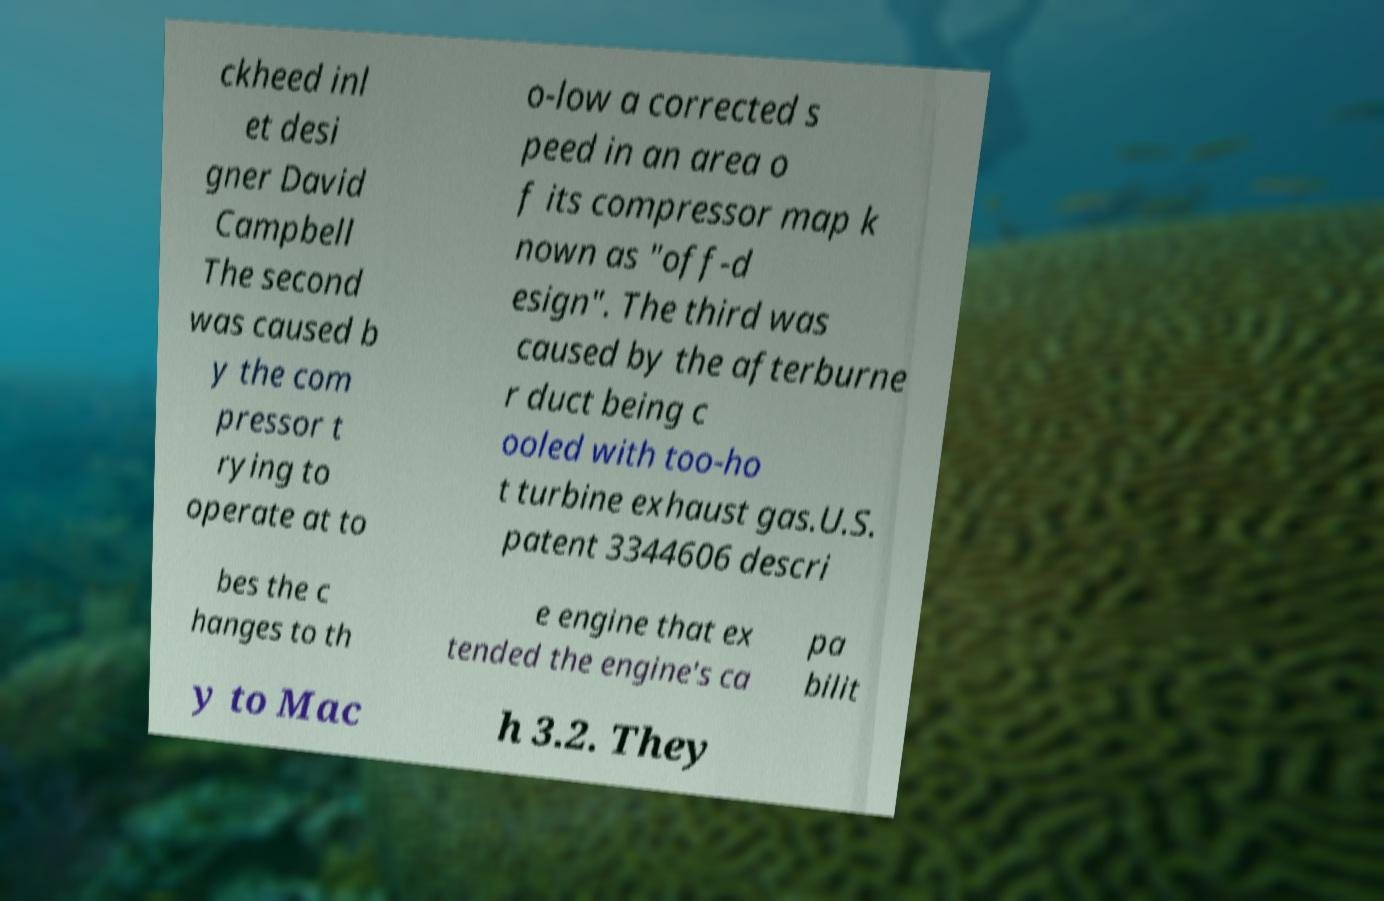There's text embedded in this image that I need extracted. Can you transcribe it verbatim? ckheed inl et desi gner David Campbell The second was caused b y the com pressor t rying to operate at to o-low a corrected s peed in an area o f its compressor map k nown as "off-d esign". The third was caused by the afterburne r duct being c ooled with too-ho t turbine exhaust gas.U.S. patent 3344606 descri bes the c hanges to th e engine that ex tended the engine's ca pa bilit y to Mac h 3.2. They 